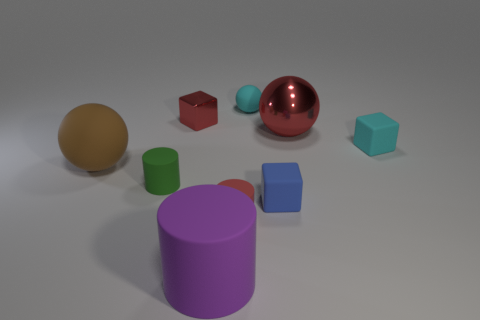Are there fewer small cyan matte blocks than matte cylinders?
Your response must be concise. Yes. What is the material of the red sphere right of the cube that is in front of the rubber ball in front of the small matte ball?
Ensure brevity in your answer.  Metal. What material is the big brown object?
Your response must be concise. Rubber. There is a matte cube that is behind the big brown object; is its color the same as the metallic thing to the left of the small blue block?
Your answer should be very brief. No. Is the number of large purple matte objects greater than the number of cylinders?
Your answer should be compact. No. What number of tiny blocks are the same color as the big shiny thing?
Provide a succinct answer. 1. There is a large matte object that is the same shape as the big shiny thing; what is its color?
Offer a terse response. Brown. There is a cylinder that is both left of the red matte object and in front of the green matte cylinder; what material is it made of?
Provide a succinct answer. Rubber. Do the big ball to the left of the large rubber cylinder and the tiny red object right of the small red metallic thing have the same material?
Ensure brevity in your answer.  Yes. The purple matte thing has what size?
Keep it short and to the point. Large. 